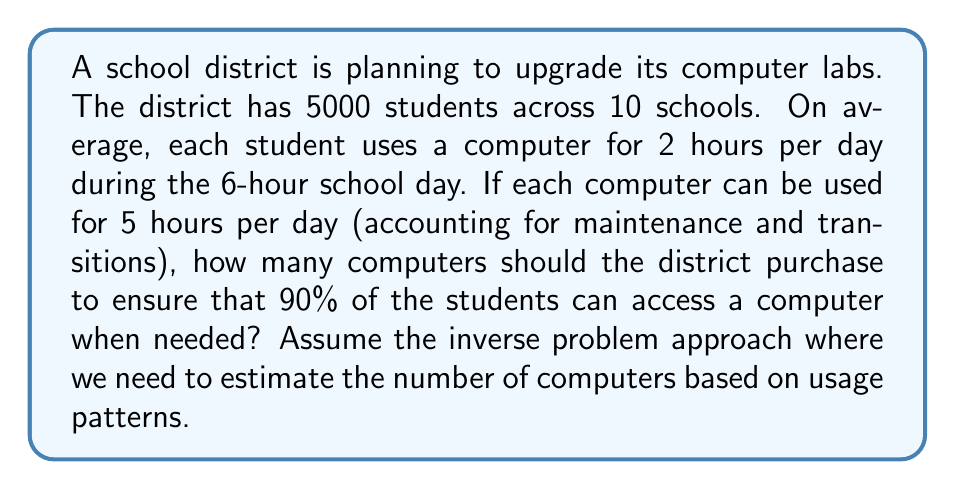What is the answer to this math problem? Let's approach this step-by-step using the inverse problem methodology:

1) First, let's calculate the total student computer usage hours per day:
   $$ \text{Total usage} = 5000 \text{ students} \times 2 \text{ hours} = 10000 \text{ hours} $$

2) Now, we need to determine how many computers are needed to accommodate this usage. However, we want to ensure 90% coverage, not 100%. So we'll adjust our total usage:
   $$ \text{Adjusted usage} = 10000 \text{ hours} \times 0.90 = 9000 \text{ hours} $$

3) Each computer can be used for 5 hours per day. To find the number of computers needed, we divide the adjusted usage by the hours per computer:
   $$ \text{Number of computers} = \frac{\text{Adjusted usage}}{\text{Hours per computer}} = \frac{9000}{5} = 1800 $$

4) However, this assumes an even distribution of usage throughout the day, which is unlikely. To account for peak usage times, we should add a buffer. A common practice is to add 20% more capacity:
   $$ \text{Final number of computers} = 1800 \times 1.20 = 2160 $$

5) Rounding up to the nearest hundred for practical procurement purposes:
   $$ \text{Recommended number of computers} = 2200 $$

This inverse problem approach allows us to estimate the optimal number of computers based on the given usage patterns and desired coverage, while accounting for real-world factors like peak usage times.
Answer: 2200 computers 